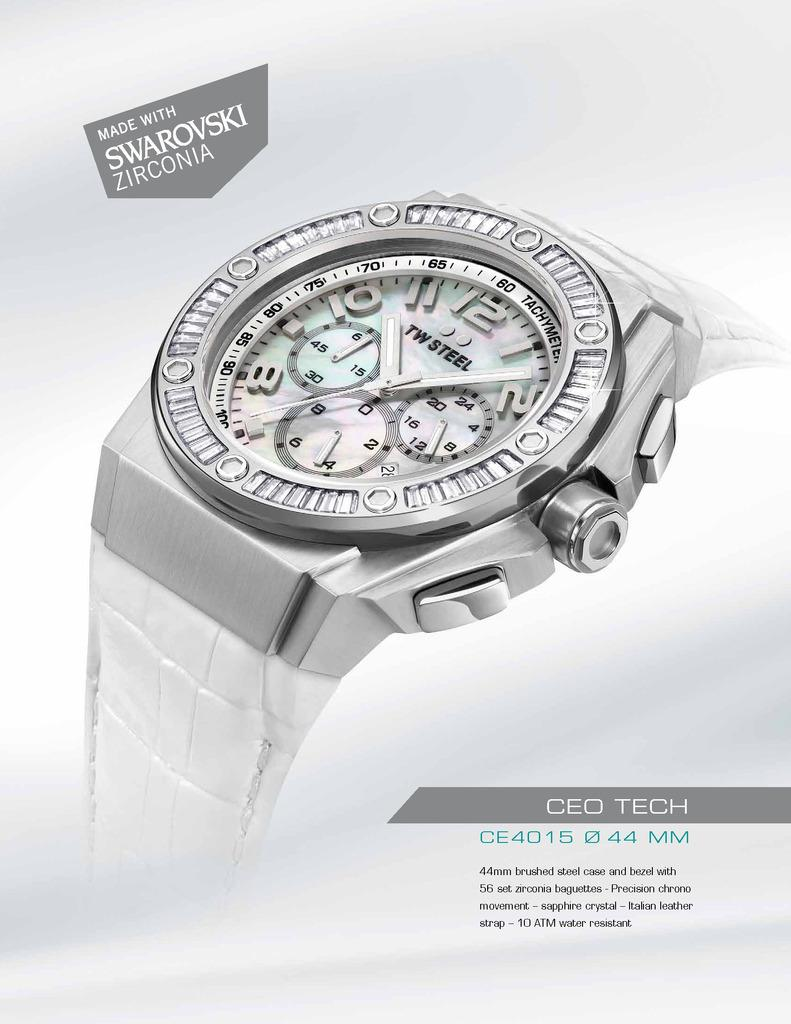<image>
Summarize the visual content of the image. The CEO Tech watch is made with Swarovski ZIrconia. 